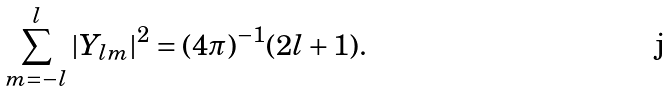<formula> <loc_0><loc_0><loc_500><loc_500>\sum _ { m = - l } ^ { l } | Y _ { l m } | ^ { 2 } = ( 4 \pi ) ^ { - 1 } ( 2 l + 1 ) .</formula> 